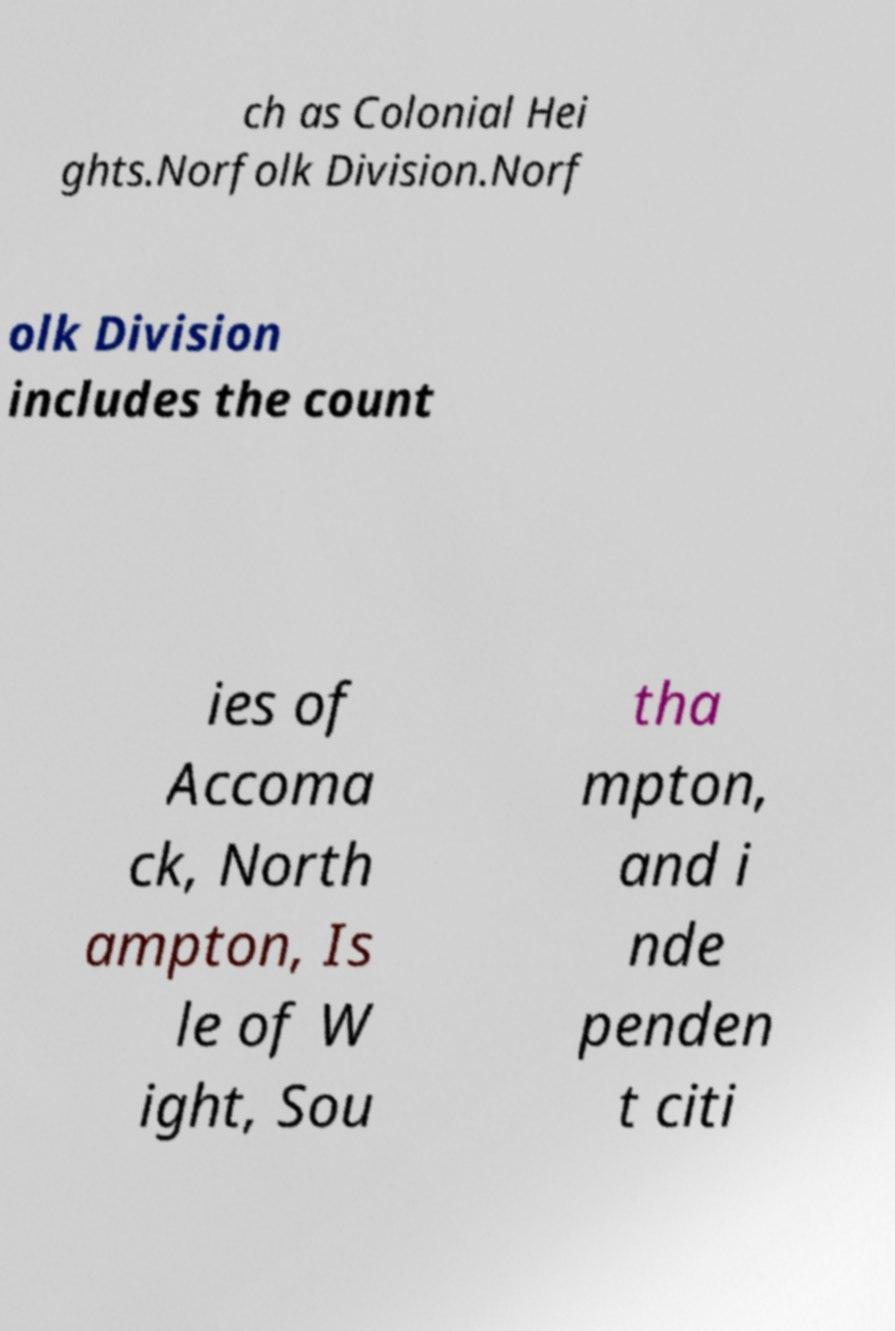There's text embedded in this image that I need extracted. Can you transcribe it verbatim? ch as Colonial Hei ghts.Norfolk Division.Norf olk Division includes the count ies of Accoma ck, North ampton, Is le of W ight, Sou tha mpton, and i nde penden t citi 